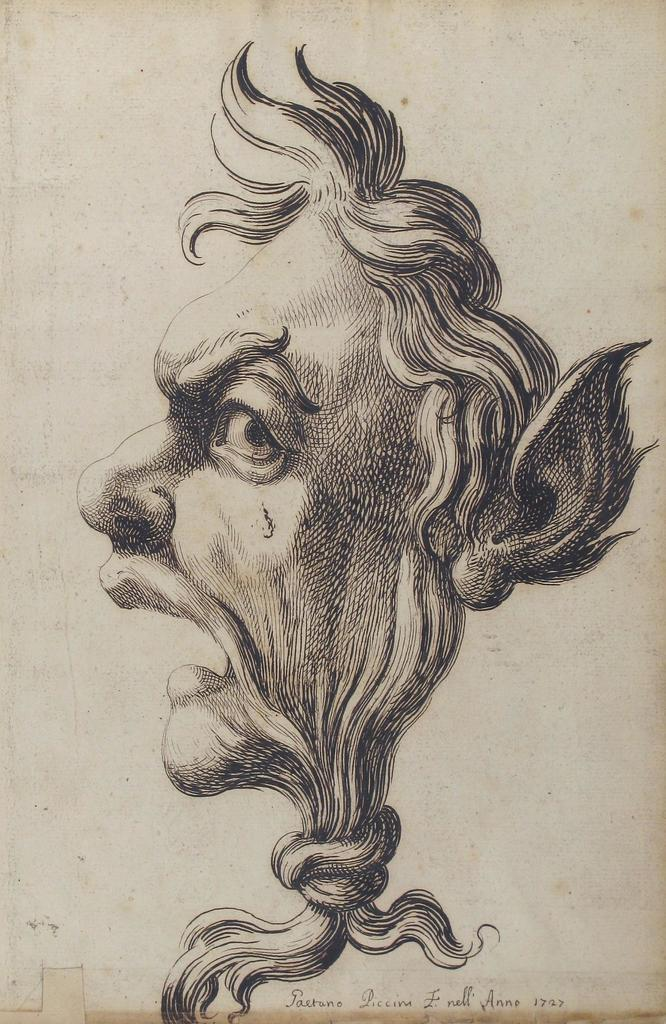What type of artwork is shown in the image? The image is a painting. What subject is depicted in the painting? The painting depicts a face. Where is the face located within the painting? The face is in the center of the painting. What color is the jellyfish swimming in the background of the painting? There is no jellyfish present in the painting; it only depicts a face in the center. 